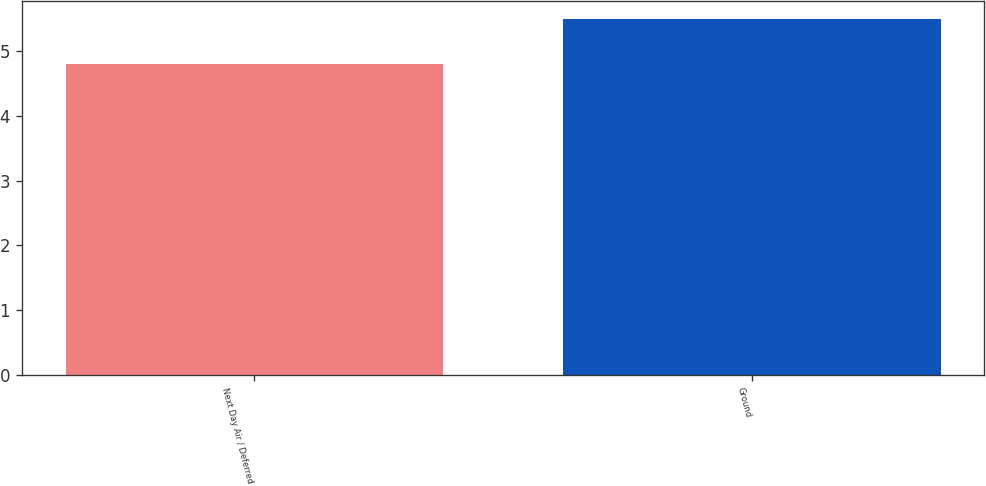Convert chart to OTSL. <chart><loc_0><loc_0><loc_500><loc_500><bar_chart><fcel>Next Day Air / Deferred<fcel>Ground<nl><fcel>4.8<fcel>5.5<nl></chart> 